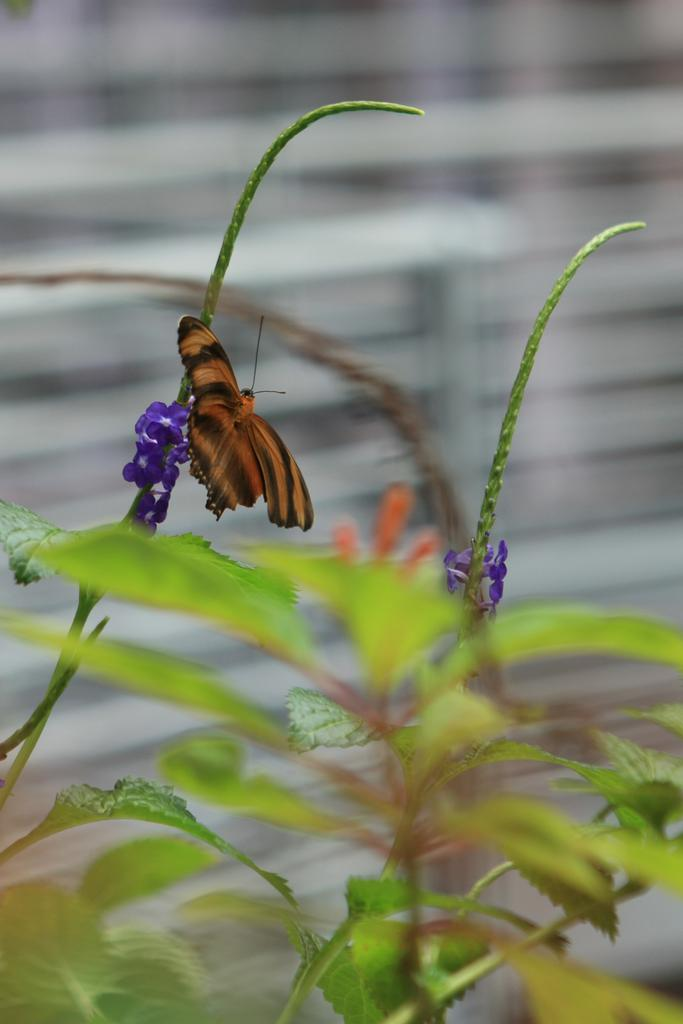What type of living organism can be seen in the image? There is a plant in the image. Can you describe any specific features of the plant? A butterfly is visible on the flower of the plant. Where is the throne located in the image? There is no throne present in the image. What type of store can be seen in the background of the image? There is no store visible in the image; it features a plant with a butterfly on its flower. 